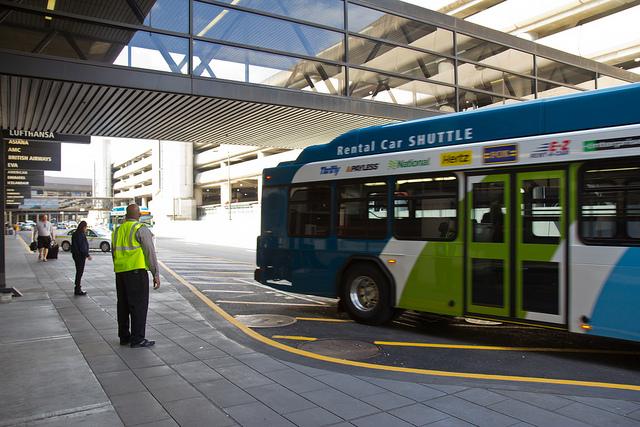What color does the man's green vest match in the photo?
Be succinct. Bus. What country is this?
Quick response, please. Usa. Where was the picture taken?
Answer briefly. Airport. What is the weather?
Keep it brief. Sunny. What is the website on the train?
Keep it brief. Hertz. Is this a train station?
Short answer required. No. 